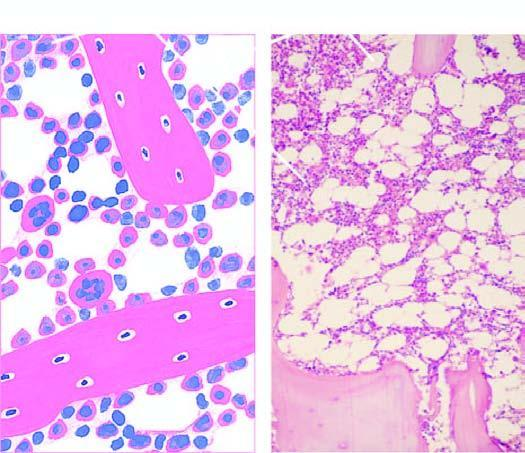does approximately 50 % of the soft tissue of the bone consist of haematopoietic tissue?
Answer the question using a single word or phrase. Yes 